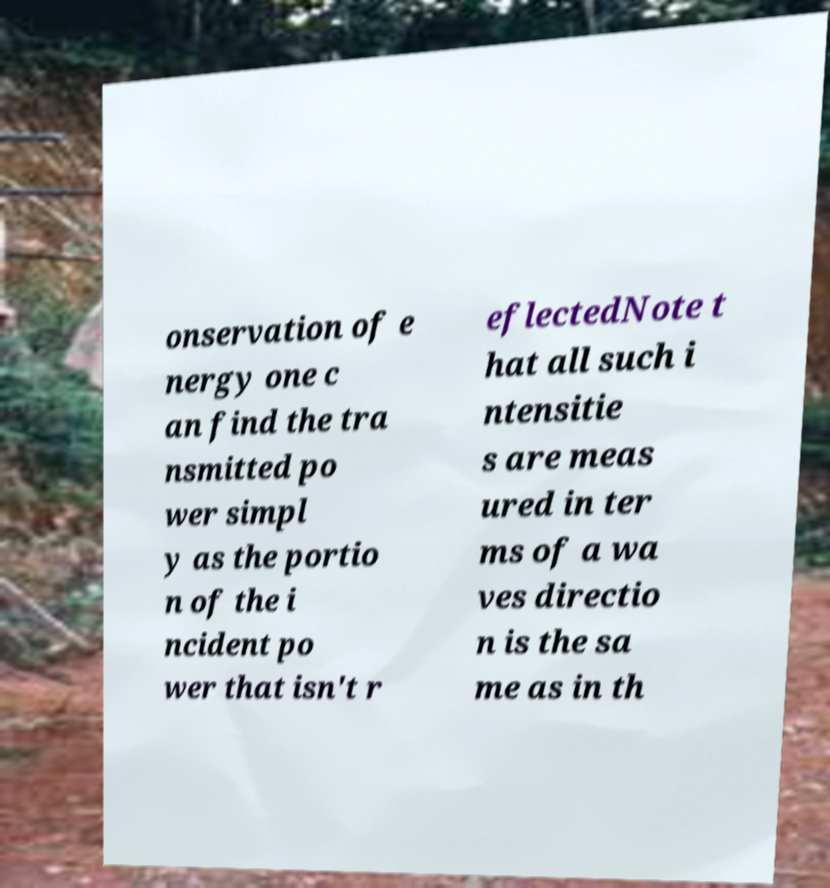For documentation purposes, I need the text within this image transcribed. Could you provide that? onservation of e nergy one c an find the tra nsmitted po wer simpl y as the portio n of the i ncident po wer that isn't r eflectedNote t hat all such i ntensitie s are meas ured in ter ms of a wa ves directio n is the sa me as in th 